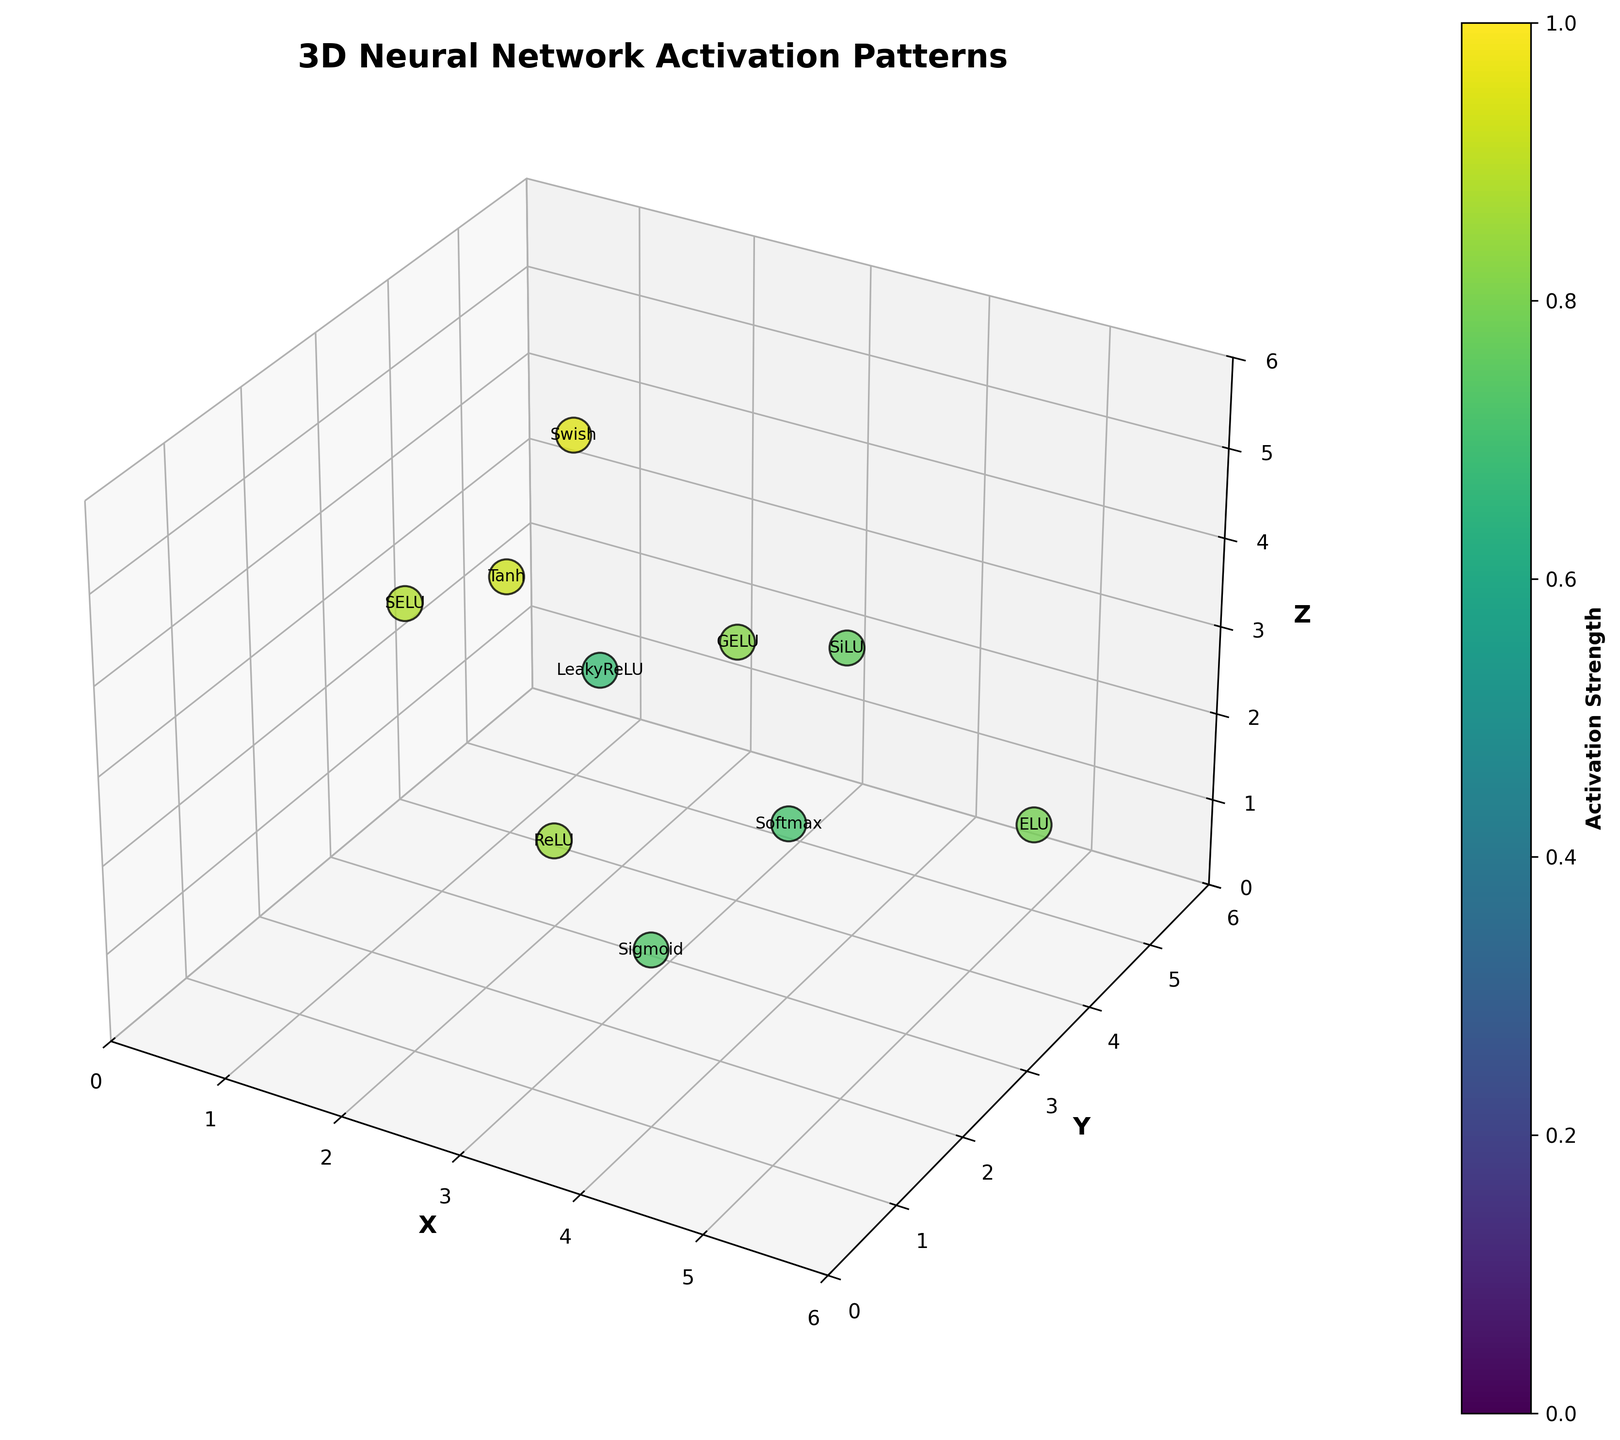What is the title of the 3D plot? The title of the plot is visible at the top and it summarizes the figure's content. The title is "3D Neural Network Activation Patterns".
Answer: 3D Neural Network Activation Patterns Which axis represents the Z-dimension? The Z-axis is labeled with the text "Z" and is marked on the figure with grid lines extending in the vertical direction.
Answer: Z How many data points are represented in the plot? To count the points, note that each scatter in the 3D space represents one point. There are 10 different points marked in the plot.
Answer: 10 Which data point has the highest activation strength? Activation strengths are color-coded on the plot, with brighter colors indicating higher values. The text labels help identify specific points. The point at (1, 5, 4) with the Swish neuron type has the highest activation strength of 0.95.
Answer: (1, 5, 4) Swish What is the color gradient used to indicate activation strength? The color gradient used to indicate activation strength ranges from dark blue to bright yellow-green, employing the 'viridis' colormap. The color bar on the side shows this gradient.
Answer: viridis Which neuron type is located at the coordinates (4, 3, 2)? The figure includes neuron type labels at each plotted point. At coordinates (4, 3, 2), the neuron type is Softmax.
Answer: Softmax Compare the activation strengths of ReLU and Softmax neurons. Which one is higher? The activation strength for ReLU is 0.85 and for Softmax it is 0.71, as indicated by their colors and text labels. ReLU has a higher activation strength.
Answer: ReLU What are the coordinates of the LeakyReLU neuron and its activation strength? The figure shows a LeakyReLU neuron at coordinates (3, 2, 4) with an activation strength color that translates to 0.68.
Answer: (3, 2, 4), 0.68 What is the combined sum of the x-coordinates of all neurons with an activation strength above 0.80? Neurons with activation strengths above 0.80 are at (2, 3, 1, 5), (1, 4, 1, 5), and (3). Adding their x-coordinates: 2 + 1 + 1 + 1 + 3 = 8.
Answer: 8 Which neuron type is located highest along the Z-axis? The text labels indicate neuron types and their coordinates. The neuron type at the highest Z-coordinate (5) is SELU located at (2, 1, 5).
Answer: SELU 